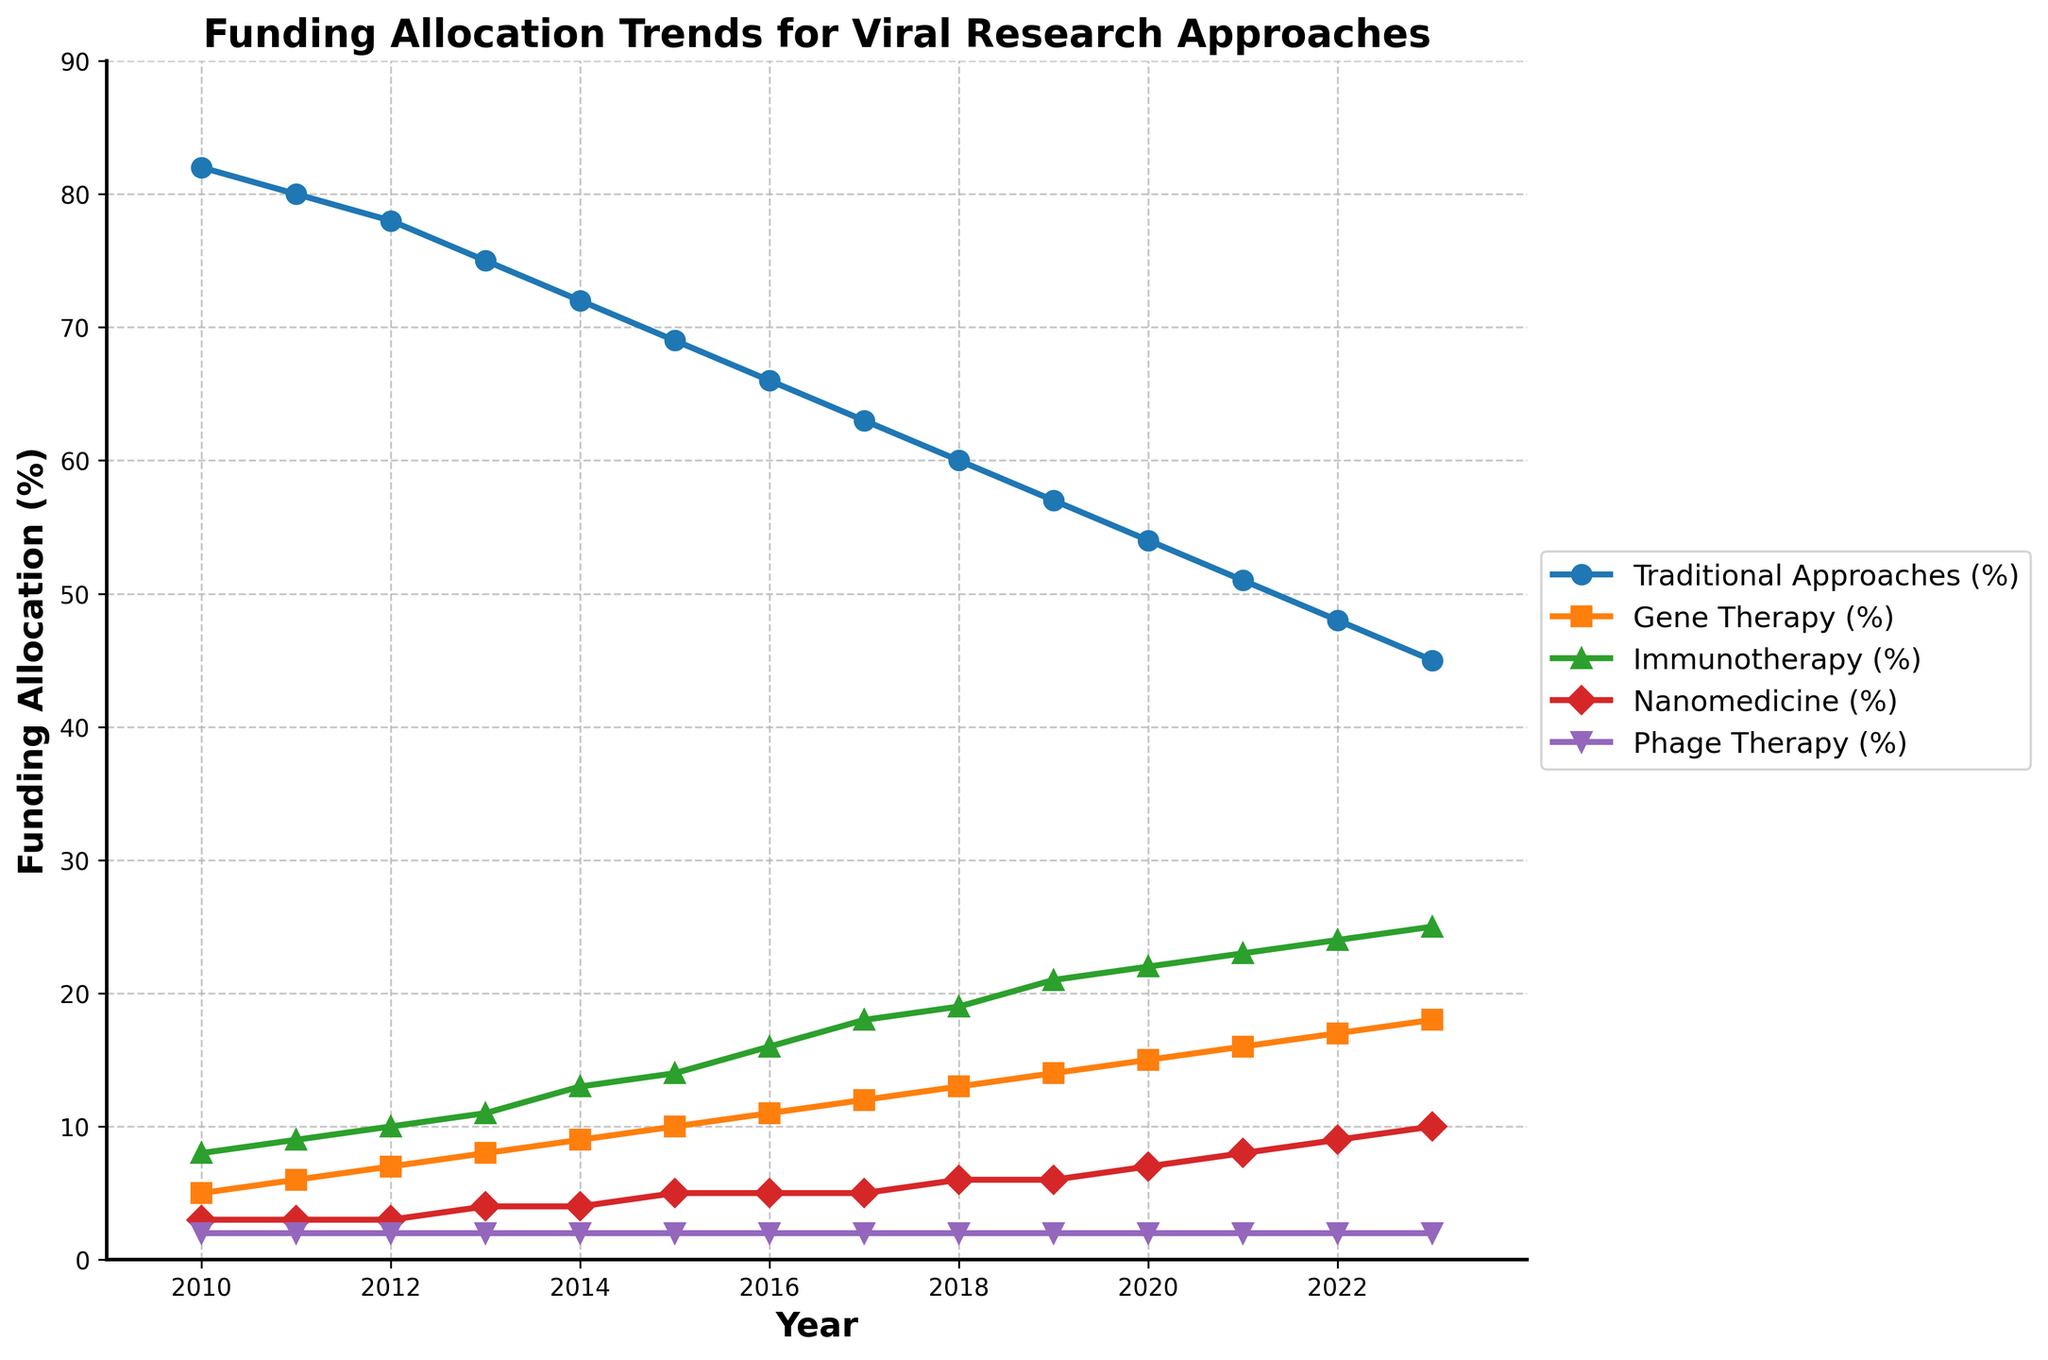When did traditional approaches have their highest funding percentage? The traditional approaches have their highest funding percentage at the beginning of the timeline. The figure starts at 2010 with 82%.
Answer: 2010 What is the trend in funding allocation for gene therapy from 2010 to 2023? To identify the trend, look at the data points for gene therapy over the years from 2010 to 2023. Gene therapy funding increased from 5% in 2010 to 18% in 2023.
Answer: Increasing In which year did nanomedicine funding first surpass 5%? Check the progression of nanomedicine funding over the years. It reached 5% in 2015 and then surpassed 5% in 2018 with 6%.
Answer: 2018 Which approach received the least funding consistently? Examine the funding percentages for all approaches over the years. Phage therapy consistently received only 2% throughout all years.
Answer: Phage Therapy Compare the funding for immunotherapy and nanomedicine in 2020. Which approach received more funding? Compare the funding percentages for both approaches in the year 2020. Immunotherapy had 22% while nanomedicine had 7%.
Answer: Immunotherapy In which year did the total funding for non-traditional approaches (gene therapy, immunotherapy, nanomedicine, phage therapy) first exceed 30%? Sum the funding percentages for all non-traditional approaches for each year and check when the sum first exceeds 30%. In 2016, the total was 11% (gene therapy) + 16% (immunotherapy) + 5% (nanomedicine) + 2% (phage therapy) = 34%.
Answer: 2016 How does the funding trend for nanomedicine compare to that of immunotherapy from 2010 to 2023? Look at both trends over the years. Immunotherapy shows a steadily rising trend from 8% to 25%, while nanomedicine increased from 3% to 10%, also rising but at a slower rate compared to immunotherapy.
Answer: Immunotherapy increased faster What is the average funding percentage for traditional approaches from 2010 to 2023? Add the percentages for traditional approaches from 2010 to 2023 and divide by the number of years: (82+80+78+75+72+69+66+63+60+57+54+51+48+45)/14.
Answer: 65.1 Which approach showed the most gradual increase in funding from 2010 to 2023? To determine the approach with the most gradual increase, check the yearly change in funding percentages. Both Gene Therapy and Immunotherapy show gradual increases, but Phage Therapy remained constant with only minor fluctuations.
Answer: Gene Therapy What was the difference in funding for traditional approaches between 2015 and 2020? Subtract the funding percentage of traditional approaches in 2020 from that in 2015: 69% (2015) - 54% (2020) = 15%.
Answer: 15% 